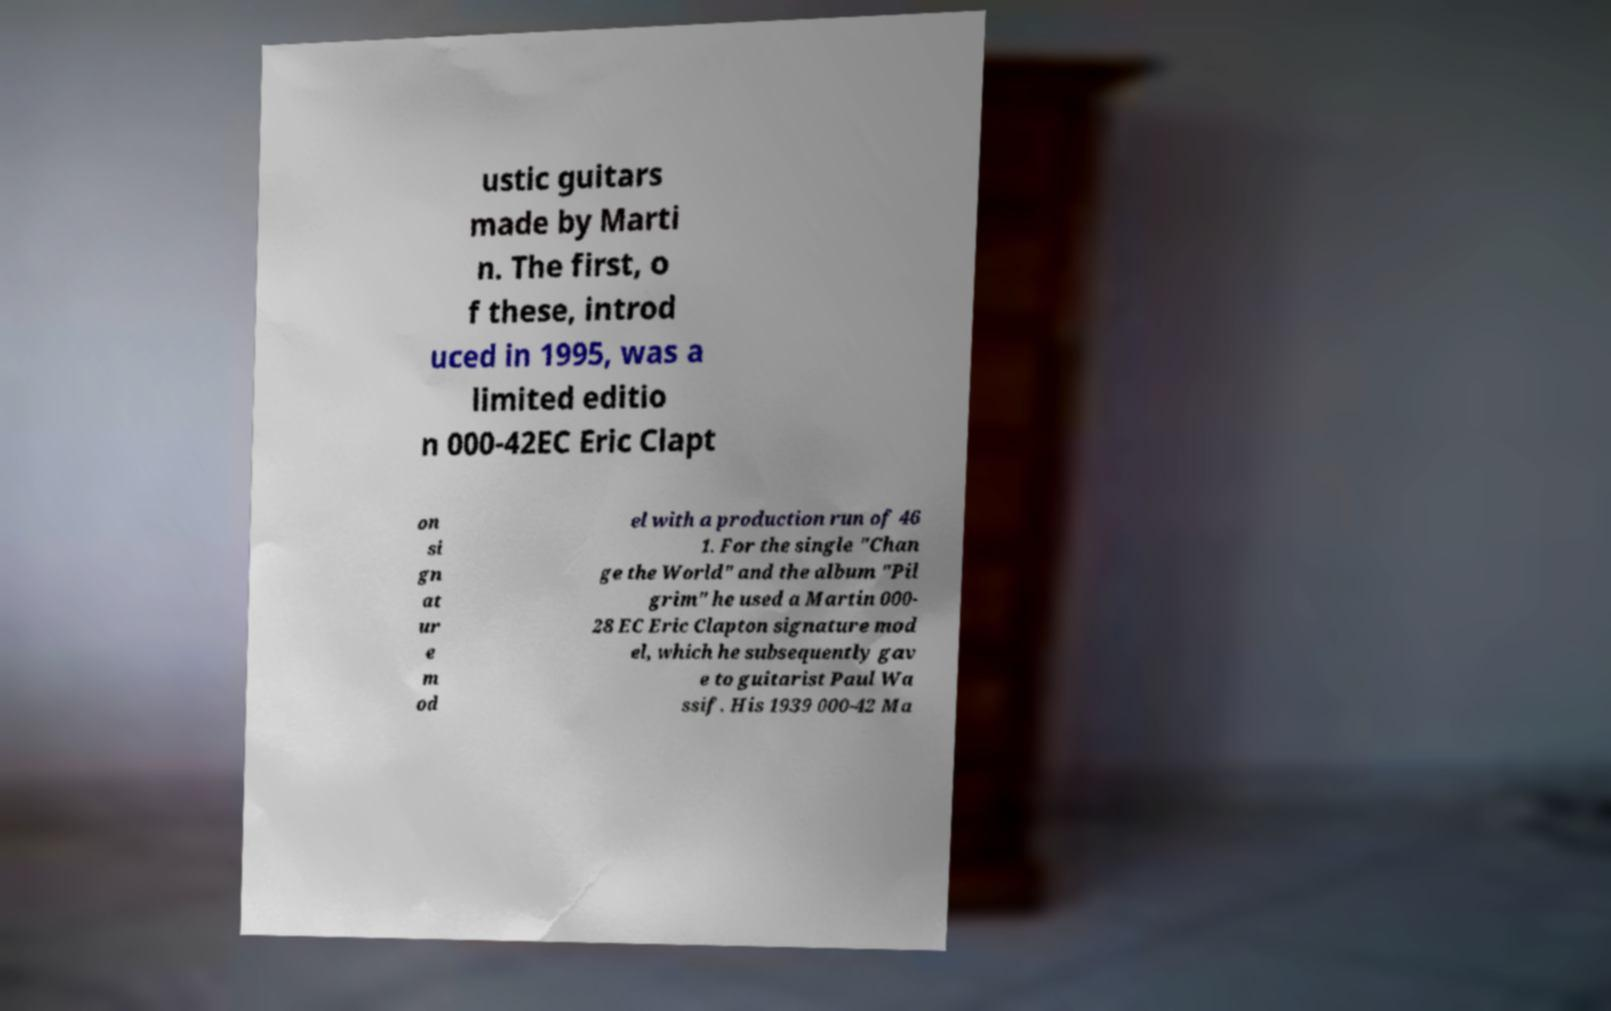Could you assist in decoding the text presented in this image and type it out clearly? ustic guitars made by Marti n. The first, o f these, introd uced in 1995, was a limited editio n 000-42EC Eric Clapt on si gn at ur e m od el with a production run of 46 1. For the single "Chan ge the World" and the album "Pil grim" he used a Martin 000- 28 EC Eric Clapton signature mod el, which he subsequently gav e to guitarist Paul Wa ssif. His 1939 000-42 Ma 